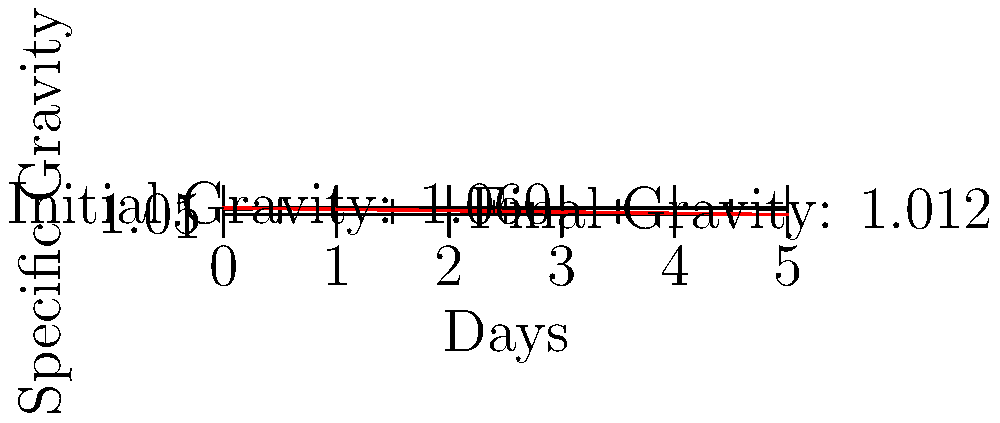Using the chart above, which shows the fermentation progress of a homebrew beer over 5 days, calculate the Alcohol By Volume (ABV) of the final product. Use the formula: $ABV = (OG - FG) \times 131.25$, where OG is Original Gravity and FG is Final Gravity. To calculate the ABV, we need to follow these steps:

1. Identify the Original Gravity (OG) and Final Gravity (FG) from the chart:
   OG = 1.060 (Day 0)
   FG = 1.012 (Day 4)

2. Apply the formula: $ABV = (OG - FG) \times 131.25$

3. Substitute the values:
   $ABV = (1.060 - 1.012) \times 131.25$

4. Calculate the difference in gravity:
   $ABV = 0.048 \times 131.25$

5. Multiply:
   $ABV = 6.3$

Therefore, the Alcohol By Volume of the final product is approximately 6.3%.
Answer: 6.3% 